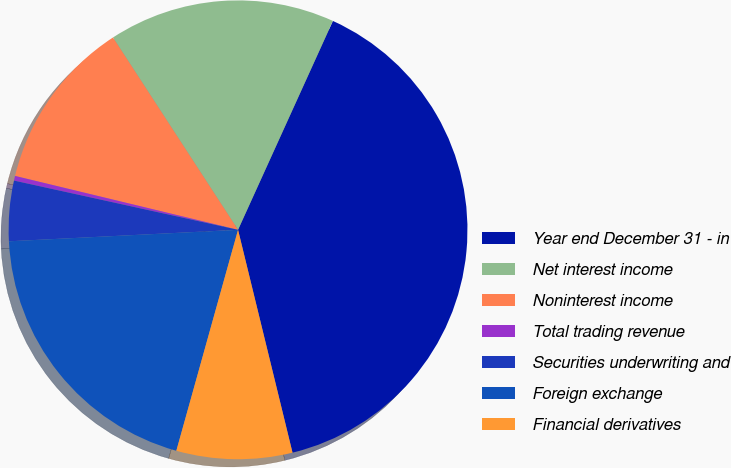Convert chart. <chart><loc_0><loc_0><loc_500><loc_500><pie_chart><fcel>Year end December 31 - in<fcel>Net interest income<fcel>Noninterest income<fcel>Total trading revenue<fcel>Securities underwriting and<fcel>Foreign exchange<fcel>Financial derivatives<nl><fcel>39.4%<fcel>15.96%<fcel>12.05%<fcel>0.33%<fcel>4.24%<fcel>19.87%<fcel>8.15%<nl></chart> 